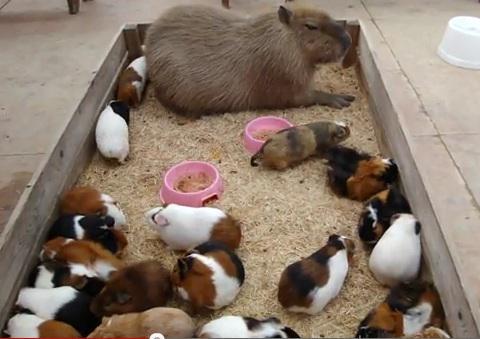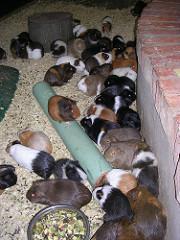The first image is the image on the left, the second image is the image on the right. Given the left and right images, does the statement "One image shows a little animal with a white nose in a grassy area near some fruit it has been given to eat." hold true? Answer yes or no. No. The first image is the image on the left, the second image is the image on the right. Assess this claim about the two images: "In at least one of the pictures, at least one guinea pig is eating". Correct or not? Answer yes or no. No. 